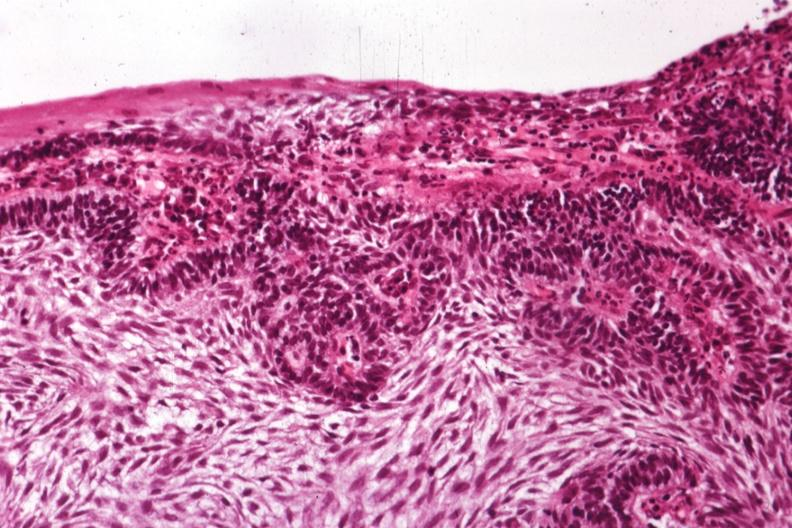s carcinoma metastatic lung present?
Answer the question using a single word or phrase. No 